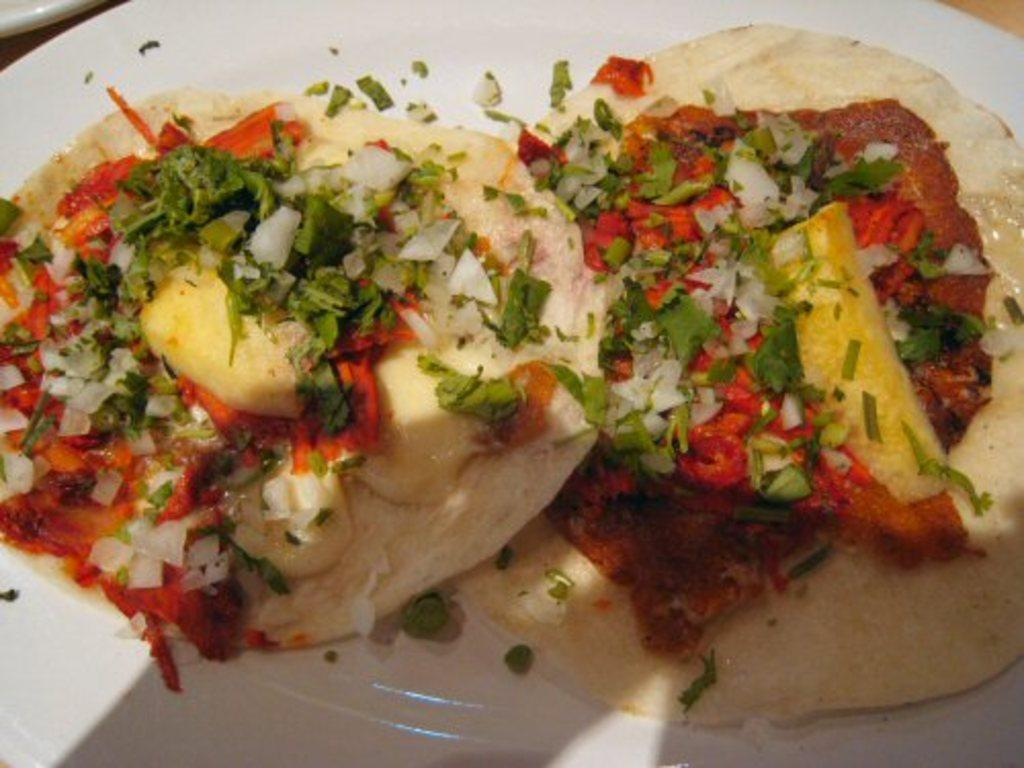What object can be seen in the image that is typically used for serving food? There is a plate in the image that is typically used for serving food. What is the color of the plate in the image? The plate is white in color. What is on the plate that indicates it is being used for serving food? There is food on the plate, including chopped onions and leaves. What hobbies does the plate have in the image? The plate does not have any hobbies, as it is an inanimate object. 